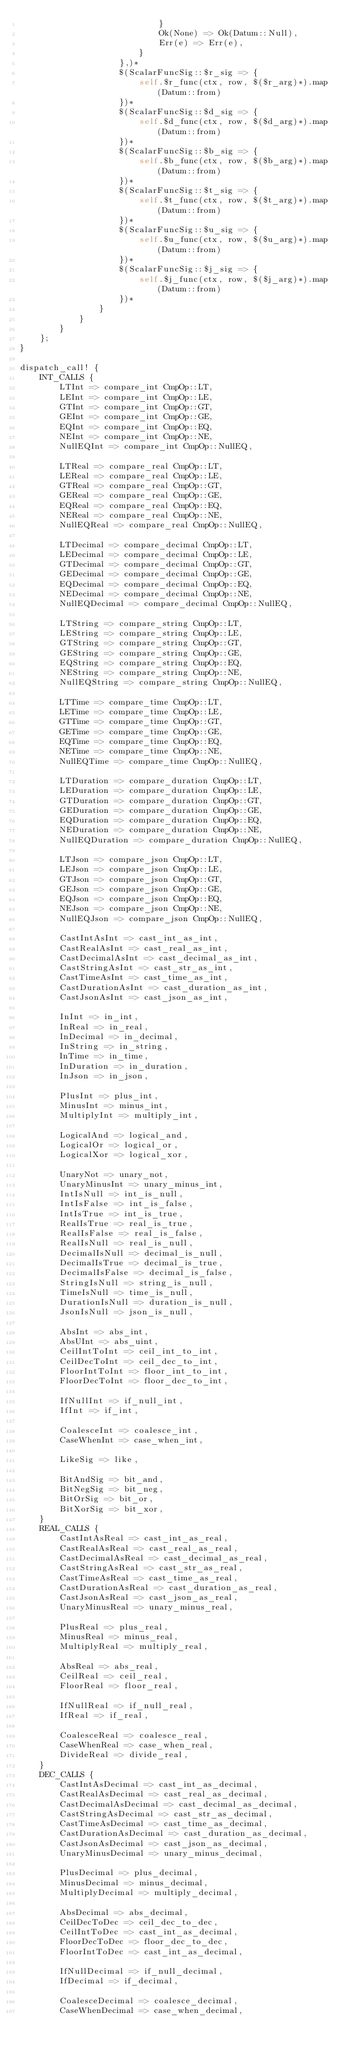Convert code to text. <code><loc_0><loc_0><loc_500><loc_500><_Rust_>                            }
                            Ok(None) => Ok(Datum::Null),
                            Err(e) => Err(e),
                        }
                    },)*
                    $(ScalarFuncSig::$r_sig => {
                        self.$r_func(ctx, row, $($r_arg)*).map(Datum::from)
                    })*
                    $(ScalarFuncSig::$d_sig => {
                        self.$d_func(ctx, row, $($d_arg)*).map(Datum::from)
                    })*
                    $(ScalarFuncSig::$b_sig => {
                        self.$b_func(ctx, row, $($b_arg)*).map(Datum::from)
                    })*
                    $(ScalarFuncSig::$t_sig => {
                        self.$t_func(ctx, row, $($t_arg)*).map(Datum::from)
                    })*
                    $(ScalarFuncSig::$u_sig => {
                        self.$u_func(ctx, row, $($u_arg)*).map(Datum::from)
                    })*
                    $(ScalarFuncSig::$j_sig => {
                        self.$j_func(ctx, row, $($j_arg)*).map(Datum::from)
                    })*
                }
            }
        }
    };
}

dispatch_call! {
    INT_CALLS {
        LTInt => compare_int CmpOp::LT,
        LEInt => compare_int CmpOp::LE,
        GTInt => compare_int CmpOp::GT,
        GEInt => compare_int CmpOp::GE,
        EQInt => compare_int CmpOp::EQ,
        NEInt => compare_int CmpOp::NE,
        NullEQInt => compare_int CmpOp::NullEQ,

        LTReal => compare_real CmpOp::LT,
        LEReal => compare_real CmpOp::LE,
        GTReal => compare_real CmpOp::GT,
        GEReal => compare_real CmpOp::GE,
        EQReal => compare_real CmpOp::EQ,
        NEReal => compare_real CmpOp::NE,
        NullEQReal => compare_real CmpOp::NullEQ,

        LTDecimal => compare_decimal CmpOp::LT,
        LEDecimal => compare_decimal CmpOp::LE,
        GTDecimal => compare_decimal CmpOp::GT,
        GEDecimal => compare_decimal CmpOp::GE,
        EQDecimal => compare_decimal CmpOp::EQ,
        NEDecimal => compare_decimal CmpOp::NE,
        NullEQDecimal => compare_decimal CmpOp::NullEQ,

        LTString => compare_string CmpOp::LT,
        LEString => compare_string CmpOp::LE,
        GTString => compare_string CmpOp::GT,
        GEString => compare_string CmpOp::GE,
        EQString => compare_string CmpOp::EQ,
        NEString => compare_string CmpOp::NE,
        NullEQString => compare_string CmpOp::NullEQ,

        LTTime => compare_time CmpOp::LT,
        LETime => compare_time CmpOp::LE,
        GTTime => compare_time CmpOp::GT,
        GETime => compare_time CmpOp::GE,
        EQTime => compare_time CmpOp::EQ,
        NETime => compare_time CmpOp::NE,
        NullEQTime => compare_time CmpOp::NullEQ,

        LTDuration => compare_duration CmpOp::LT,
        LEDuration => compare_duration CmpOp::LE,
        GTDuration => compare_duration CmpOp::GT,
        GEDuration => compare_duration CmpOp::GE,
        EQDuration => compare_duration CmpOp::EQ,
        NEDuration => compare_duration CmpOp::NE,
        NullEQDuration => compare_duration CmpOp::NullEQ,

        LTJson => compare_json CmpOp::LT,
        LEJson => compare_json CmpOp::LE,
        GTJson => compare_json CmpOp::GT,
        GEJson => compare_json CmpOp::GE,
        EQJson => compare_json CmpOp::EQ,
        NEJson => compare_json CmpOp::NE,
        NullEQJson => compare_json CmpOp::NullEQ,

        CastIntAsInt => cast_int_as_int,
        CastRealAsInt => cast_real_as_int,
        CastDecimalAsInt => cast_decimal_as_int,
        CastStringAsInt => cast_str_as_int,
        CastTimeAsInt => cast_time_as_int,
        CastDurationAsInt => cast_duration_as_int,
        CastJsonAsInt => cast_json_as_int,

        InInt => in_int,
        InReal => in_real,
        InDecimal => in_decimal,
        InString => in_string,
        InTime => in_time,
        InDuration => in_duration,
        InJson => in_json,

        PlusInt => plus_int,
        MinusInt => minus_int,
        MultiplyInt => multiply_int,

        LogicalAnd => logical_and,
        LogicalOr => logical_or,
        LogicalXor => logical_xor,

        UnaryNot => unary_not,
        UnaryMinusInt => unary_minus_int,
        IntIsNull => int_is_null,
        IntIsFalse => int_is_false,
        IntIsTrue => int_is_true,
        RealIsTrue => real_is_true,
        RealIsFalse => real_is_false,
        RealIsNull => real_is_null,
        DecimalIsNull => decimal_is_null,
        DecimalIsTrue => decimal_is_true,
        DecimalIsFalse => decimal_is_false,
        StringIsNull => string_is_null,
        TimeIsNull => time_is_null,
        DurationIsNull => duration_is_null,
        JsonIsNull => json_is_null,

        AbsInt => abs_int,
        AbsUInt => abs_uint,
        CeilIntToInt => ceil_int_to_int,
        CeilDecToInt => ceil_dec_to_int,
        FloorIntToInt => floor_int_to_int,
        FloorDecToInt => floor_dec_to_int,

        IfNullInt => if_null_int,
        IfInt => if_int,

        CoalesceInt => coalesce_int,
        CaseWhenInt => case_when_int,

        LikeSig => like,

        BitAndSig => bit_and,
        BitNegSig => bit_neg,
        BitOrSig => bit_or,
        BitXorSig => bit_xor,
    }
    REAL_CALLS {
        CastIntAsReal => cast_int_as_real,
        CastRealAsReal => cast_real_as_real,
        CastDecimalAsReal => cast_decimal_as_real,
        CastStringAsReal => cast_str_as_real,
        CastTimeAsReal => cast_time_as_real,
        CastDurationAsReal => cast_duration_as_real,
        CastJsonAsReal => cast_json_as_real,
        UnaryMinusReal => unary_minus_real,

        PlusReal => plus_real,
        MinusReal => minus_real,
        MultiplyReal => multiply_real,

        AbsReal => abs_real,
        CeilReal => ceil_real,
        FloorReal => floor_real,

        IfNullReal => if_null_real,
        IfReal => if_real,

        CoalesceReal => coalesce_real,
        CaseWhenReal => case_when_real,
        DivideReal => divide_real,
    }
    DEC_CALLS {
        CastIntAsDecimal => cast_int_as_decimal,
        CastRealAsDecimal => cast_real_as_decimal,
        CastDecimalAsDecimal => cast_decimal_as_decimal,
        CastStringAsDecimal => cast_str_as_decimal,
        CastTimeAsDecimal => cast_time_as_decimal,
        CastDurationAsDecimal => cast_duration_as_decimal,
        CastJsonAsDecimal => cast_json_as_decimal,
        UnaryMinusDecimal => unary_minus_decimal,

        PlusDecimal => plus_decimal,
        MinusDecimal => minus_decimal,
        MultiplyDecimal => multiply_decimal,

        AbsDecimal => abs_decimal,
        CeilDecToDec => ceil_dec_to_dec,
        CeilIntToDec => cast_int_as_decimal,
        FloorDecToDec => floor_dec_to_dec,
        FloorIntToDec => cast_int_as_decimal,

        IfNullDecimal => if_null_decimal,
        IfDecimal => if_decimal,

        CoalesceDecimal => coalesce_decimal,
        CaseWhenDecimal => case_when_decimal,</code> 